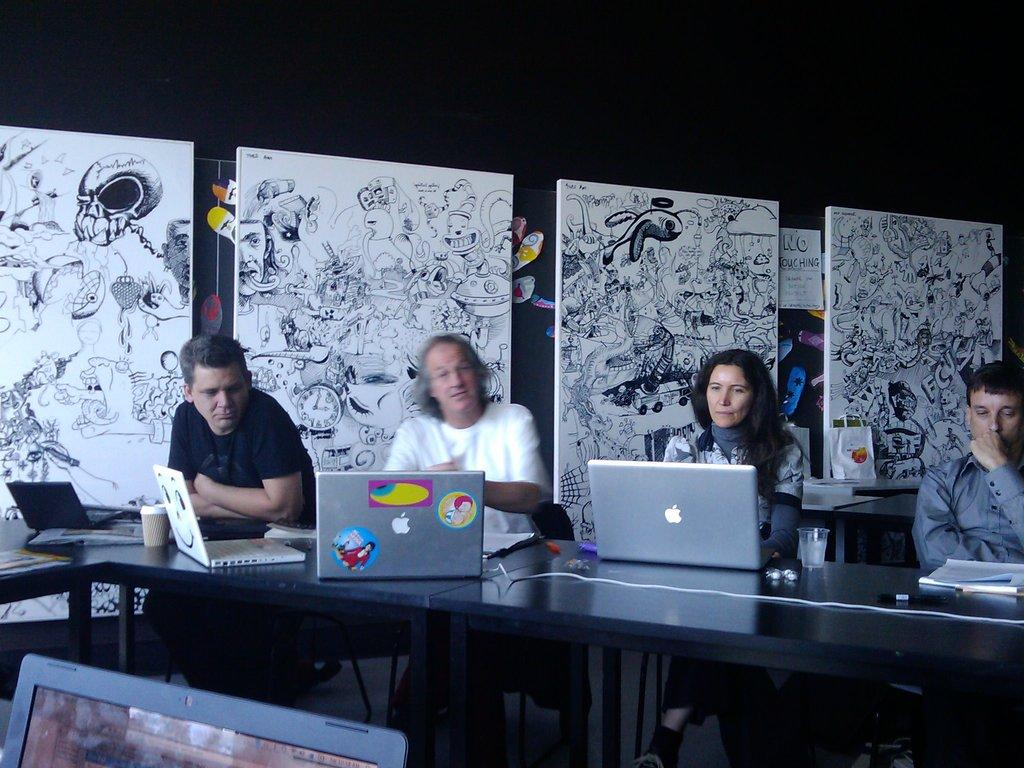What are the people in the image doing? The people in the image are sitting. What objects can be seen on the table in the image? There are laptops on a table in the image. What items are visible that people might use for drinking? There are glasses in the image. What type of reading material is present in the image? There is a book in the image. What can be seen in the background of the image that might be related to creativity? There are sketches visible in the background of the image. What number is written on the sock in the image? There is no sock present in the image, so it is not possible to determine if a number is written on it. 